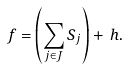<formula> <loc_0><loc_0><loc_500><loc_500>f = \left ( \sum _ { j \in J } S _ { j } \right ) + \, h .</formula> 